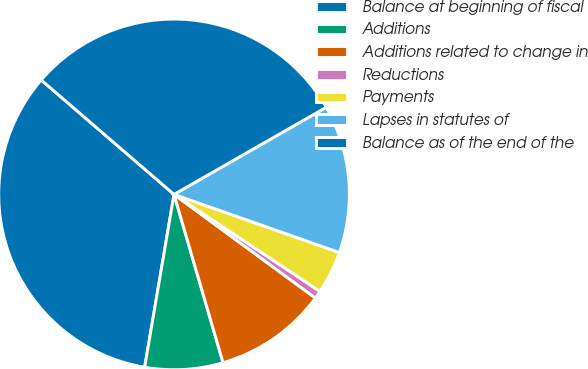Convert chart to OTSL. <chart><loc_0><loc_0><loc_500><loc_500><pie_chart><fcel>Balance at beginning of fiscal<fcel>Additions<fcel>Additions related to change in<fcel>Reductions<fcel>Payments<fcel>Lapses in statutes of<fcel>Balance as of the end of the<nl><fcel>33.64%<fcel>7.19%<fcel>10.42%<fcel>0.73%<fcel>3.96%<fcel>13.65%<fcel>30.41%<nl></chart> 